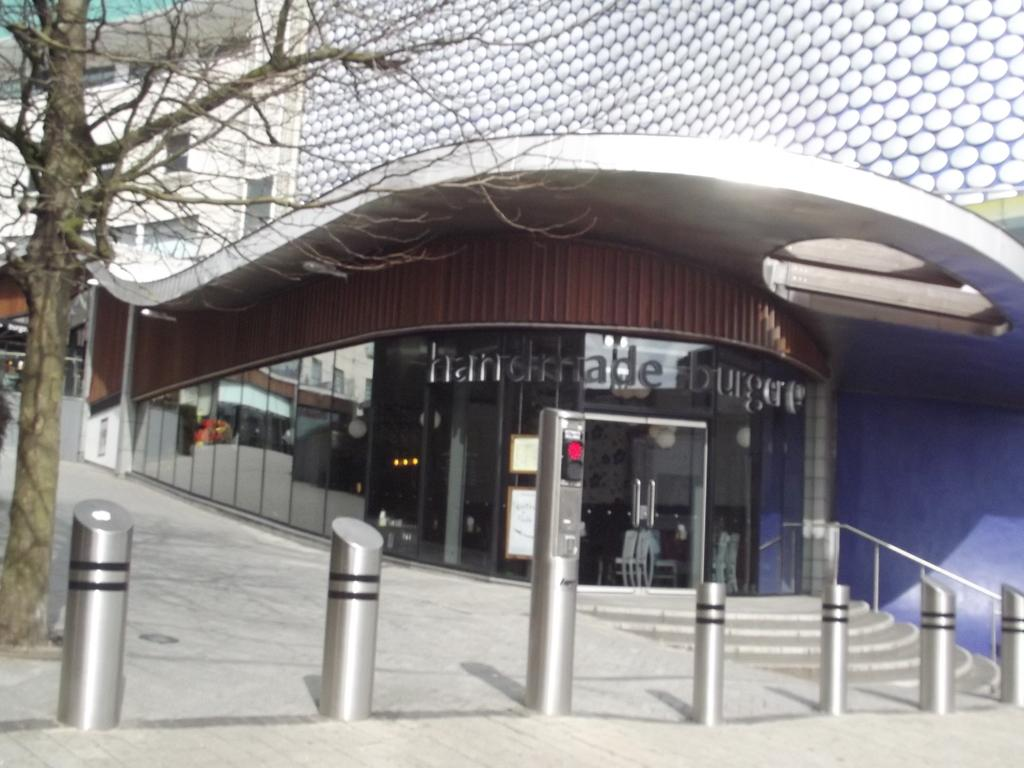What type of building is visible in the image? There is a building with glass windows in the image. What natural element can be seen in the image? There is a tree in the image. What type of place is the judge sitting in the image? There is no judge present in the image, as it only features a building with glass windows and a tree. 